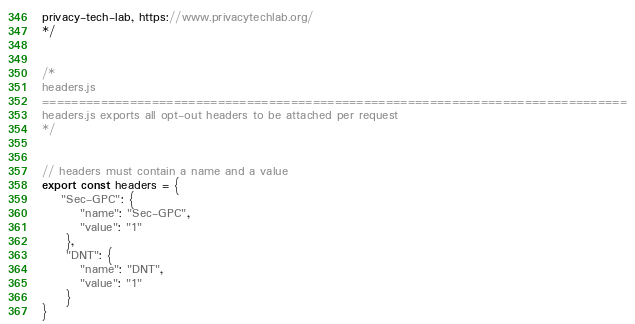Convert code to text. <code><loc_0><loc_0><loc_500><loc_500><_JavaScript_>privacy-tech-lab, https://www.privacytechlab.org/
*/


/*
headers.js
================================================================================
headers.js exports all opt-out headers to be attached per request
*/


// headers must contain a name and a value
export const headers = {
    "Sec-GPC": {
        "name": "Sec-GPC",
        "value": "1"
     },
     "DNT": {
        "name": "DNT",
        "value": "1"
     }
}</code> 